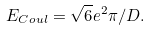Convert formula to latex. <formula><loc_0><loc_0><loc_500><loc_500>E _ { C o u l } = \sqrt { 6 } e ^ { 2 } \pi / D .</formula> 